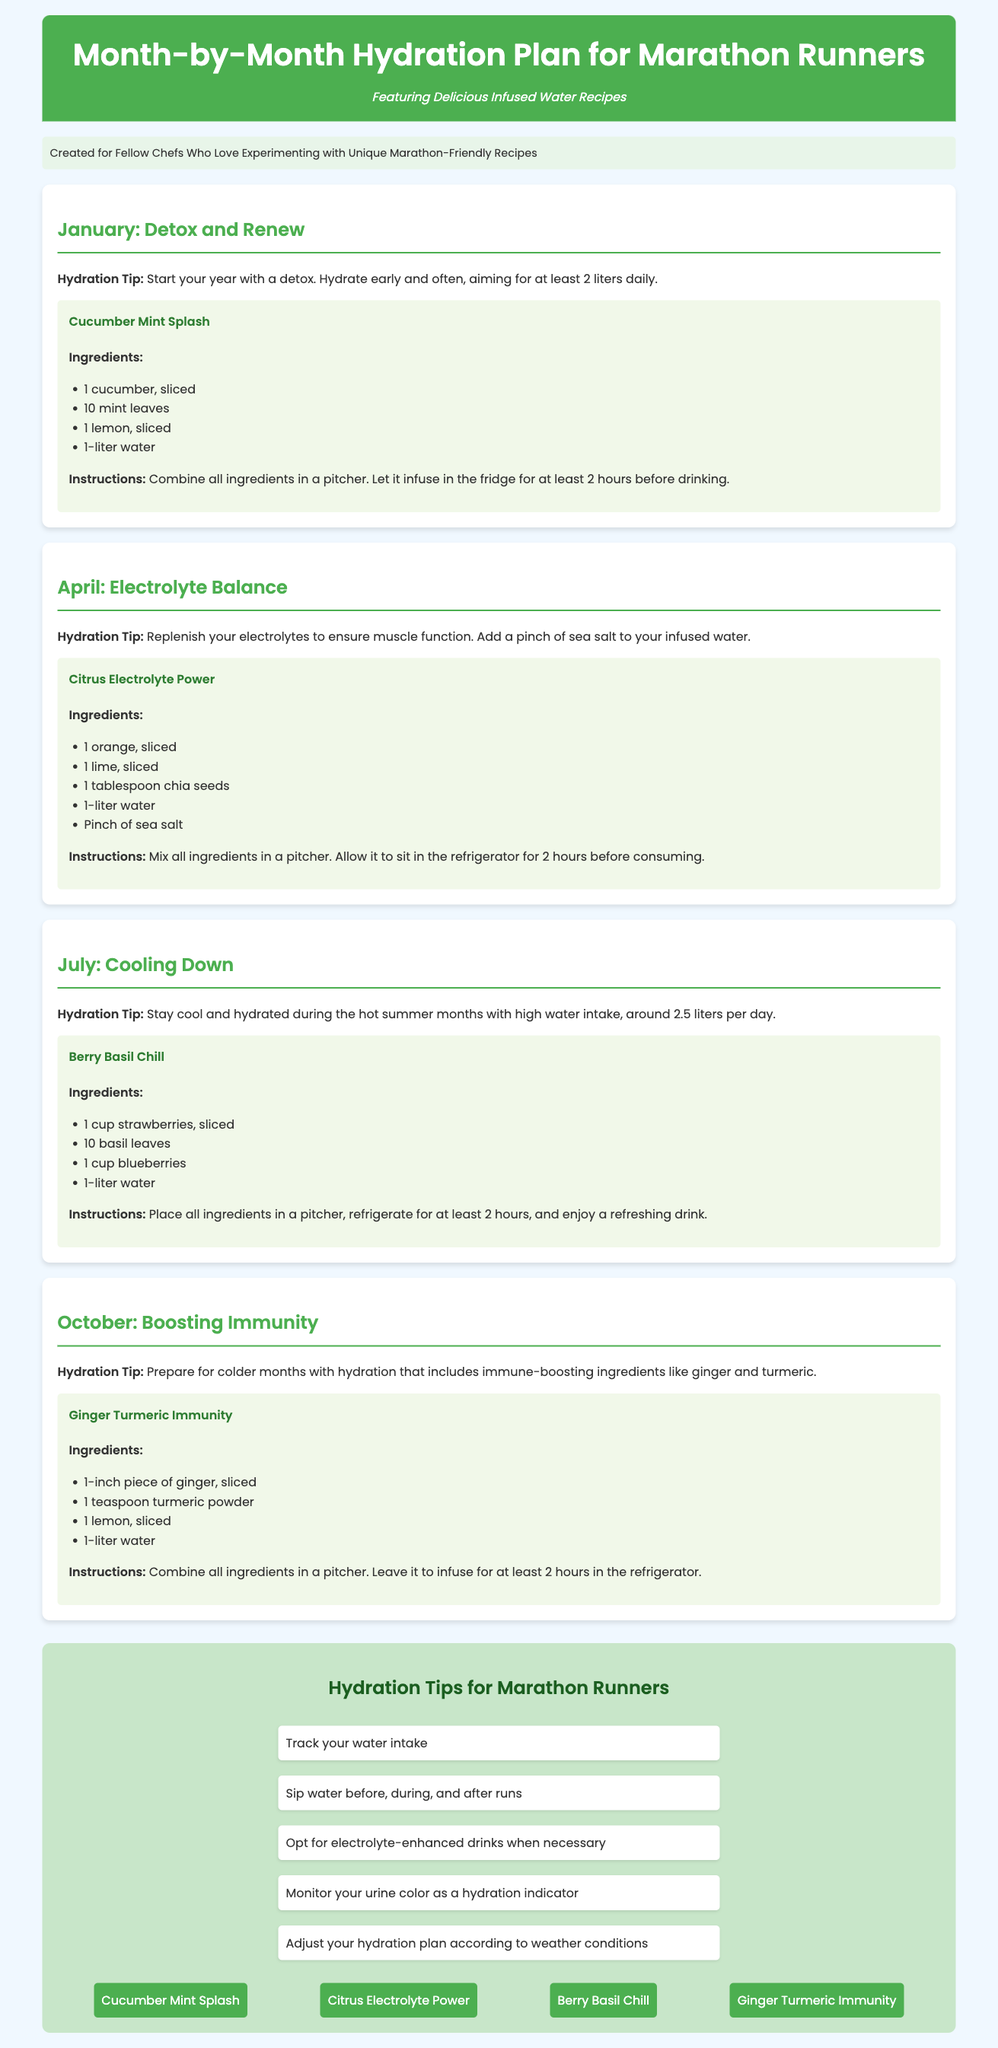What is the primary focus of the document? The document is centered around a month-by-month hydration plan specifically designed for marathon runners.
Answer: Hydration plan What month features the recipe "Cucumber Mint Splash"? This recipe is provided for the month of January in the document.
Answer: January How many liters of water should one aim to drink during January? The hydration tip for January advises aiming for at least 2 liters of water daily.
Answer: 2 liters What ingredient is used in the "Citrus Electrolyte Power" recipe as an electrolyte source? The recipe includes a pinch of sea salt as an electrolyte source.
Answer: Sea salt Which month's hydration plan includes ingredients to boost immunity? The October hydration plan focuses on boosting immunity with specific ingredients.
Answer: October Which infused water recipe includes berries? The recipe "Berry Basil Chill" includes strawberries and blueberries.
Answer: Berry Basil Chill What is the recommended daily water intake in July? The hydration tip for July recommends a daily water intake of around 2.5 liters.
Answer: 2.5 liters What are the two main immune-boosting ingredients mentioned for October? The ingredients listed for boosting immunity are ginger and turmeric.
Answer: Ginger and turmeric How many hydration tips are provided in the infographic section? The infographic section lists five hydration tips for marathon runners.
Answer: Five 